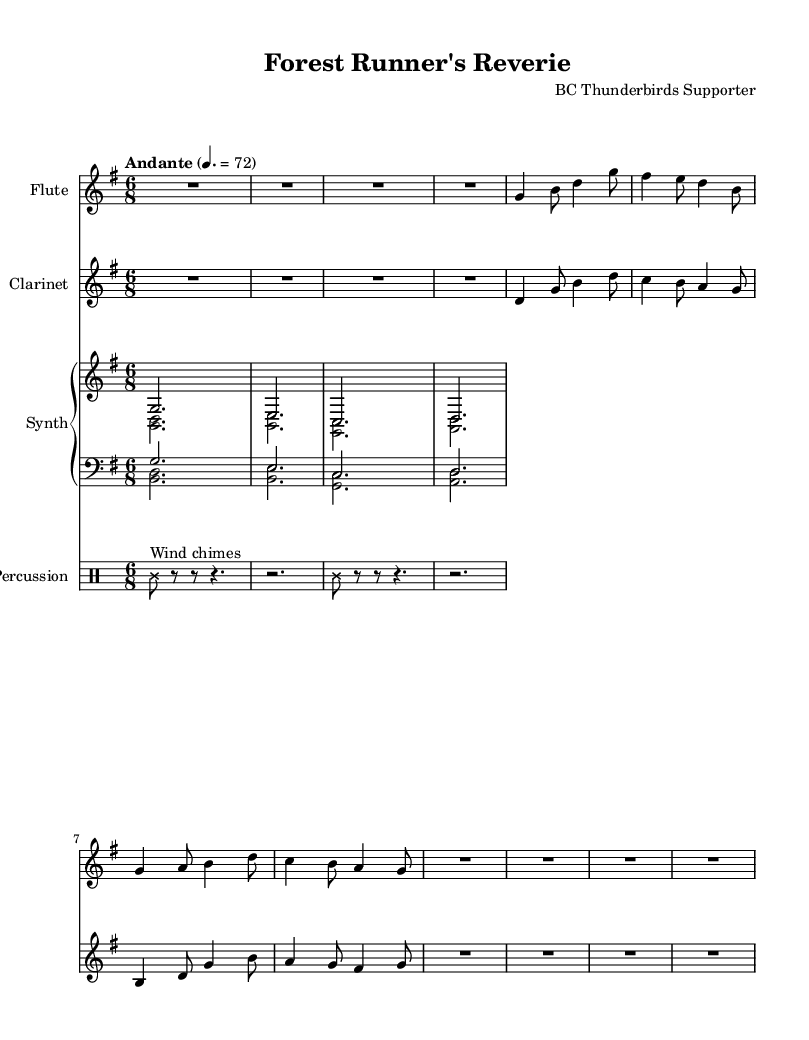What is the key signature of this music? The key signature is G major, which has one sharp (F#). This can be identified by examining the key signature portion of the music sheet where a single sharp is present.
Answer: G major What is the time signature of this music? The time signature is 6/8, which can be confirmed by looking at the notation at the beginning of the score that indicates six eighth notes per measure.
Answer: 6/8 What is the tempo marking for this piece? The tempo marking is "Andante" with a metronome marking of 72, indicated at the beginning of the piece as the tempo.
Answer: Andante, 72 How many measures are there in the flute part? The flute part consists of 8 measures, which can be counted by numbering the bar lines in the flute staff.
Answer: 8 Which instruments are included in the score? The score includes Flute, Clarinet, Synthesizer, and Percussion, as listed in the instrument names at the beginning of each staff.
Answer: Flute, Clarinet, Synthesizer, Percussion What type of special effect is used in the percussion part? The percussion part uses "Wind chimes," indicated by the text markup associated with the note in the percussion line.
Answer: Wind chimes What is the first pitch played by the synthesizer? The first pitch played by the synthesizer is G, which can be seen at the start of the synthesizer part in the upper staff.
Answer: G 